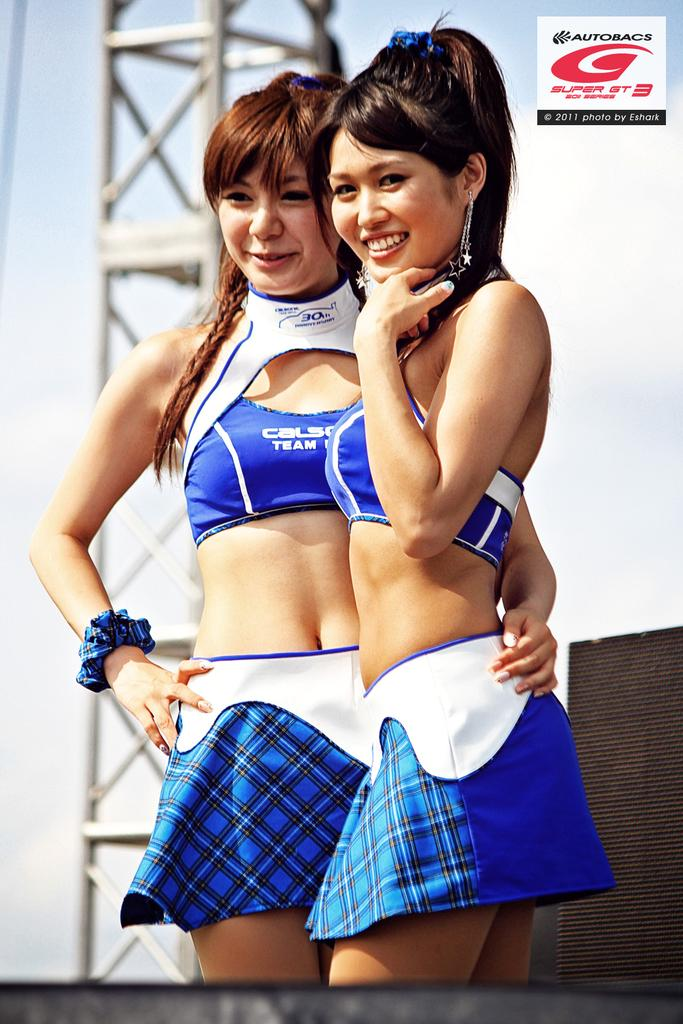<image>
Relay a brief, clear account of the picture shown. A woman with the word "team" on her shirt has her arm around another woman. 